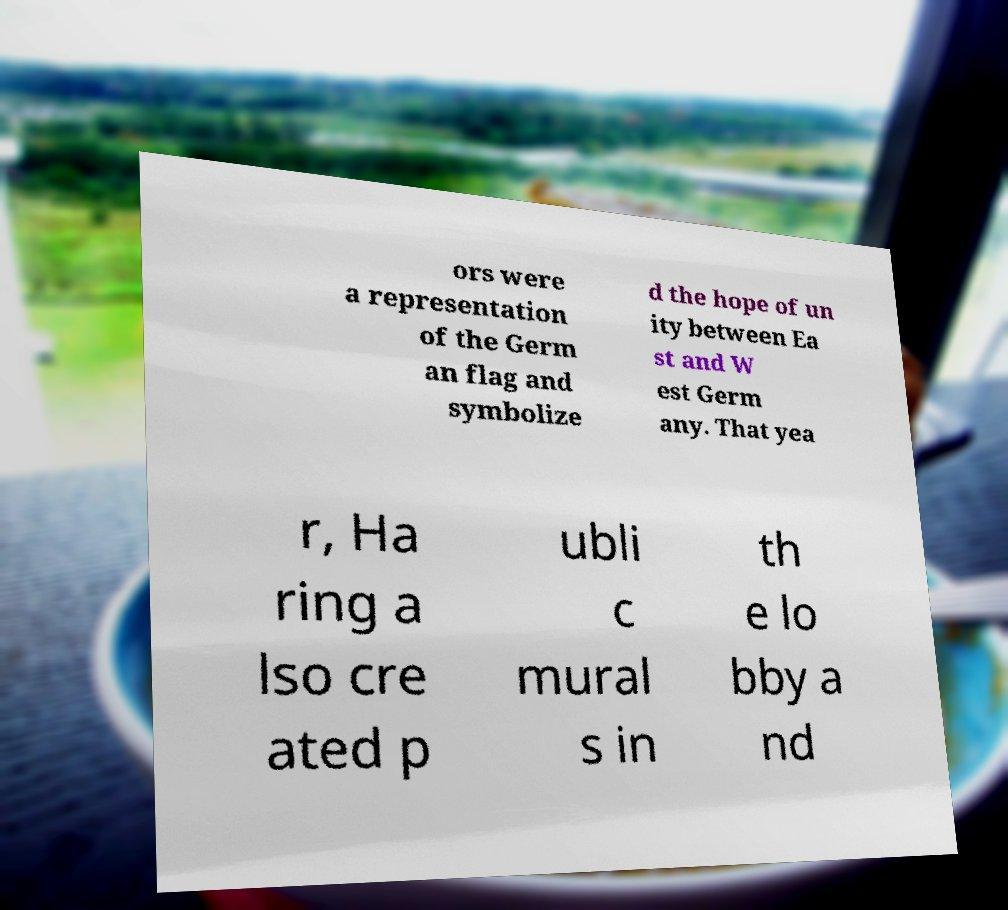Can you accurately transcribe the text from the provided image for me? ors were a representation of the Germ an flag and symbolize d the hope of un ity between Ea st and W est Germ any. That yea r, Ha ring a lso cre ated p ubli c mural s in th e lo bby a nd 